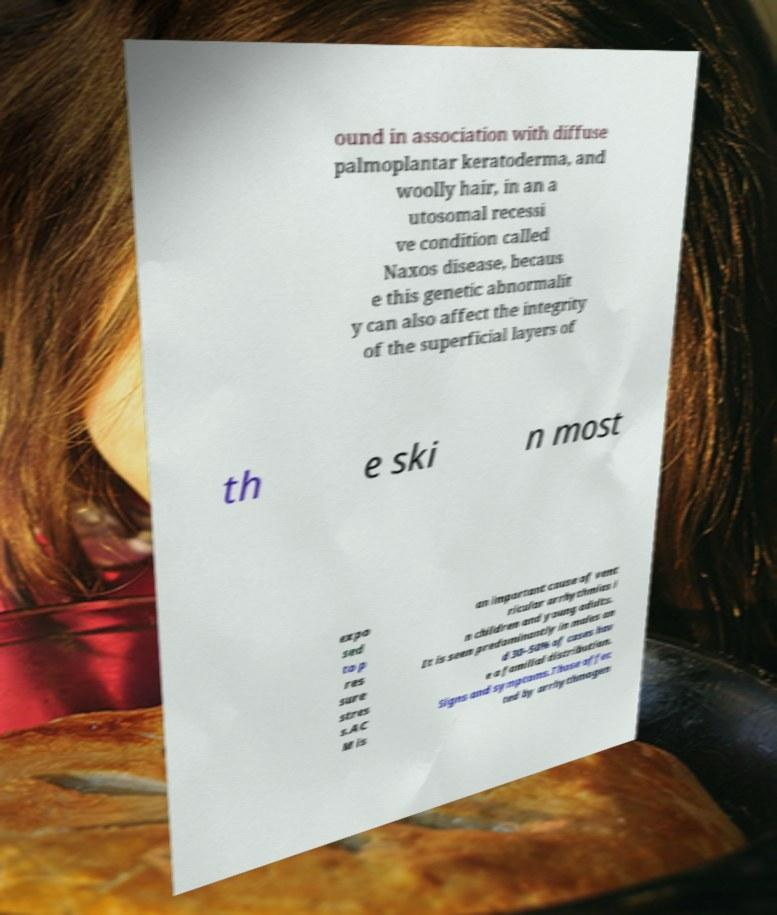There's text embedded in this image that I need extracted. Can you transcribe it verbatim? ound in association with diffuse palmoplantar keratoderma, and woolly hair, in an a utosomal recessi ve condition called Naxos disease, becaus e this genetic abnormalit y can also affect the integrity of the superficial layers of th e ski n most expo sed to p res sure stres s.AC M is an important cause of vent ricular arrhythmias i n children and young adults. It is seen predominantly in males an d 30–50% of cases hav e a familial distribution. Signs and symptoms.Those affec ted by arrhythmogen 